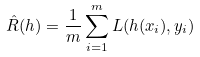<formula> <loc_0><loc_0><loc_500><loc_500>\hat { R } ( h ) = \frac { 1 } { m } \sum _ { i = 1 } ^ { m } L ( h ( x _ { i } ) , y _ { i } )</formula> 